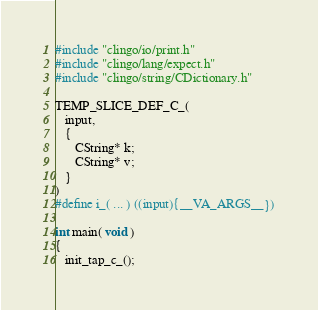Convert code to text. <code><loc_0><loc_0><loc_500><loc_500><_C_>#include "clingo/io/print.h"
#include "clingo/lang/expect.h"
#include "clingo/string/CDictionary.h"

TEMP_SLICE_DEF_C_(
   input,
   {
      CString* k;
      CString* v;
   }
)
#define i_( ... ) ((input){__VA_ARGS__})

int main( void )
{
   init_tap_c_();
</code> 